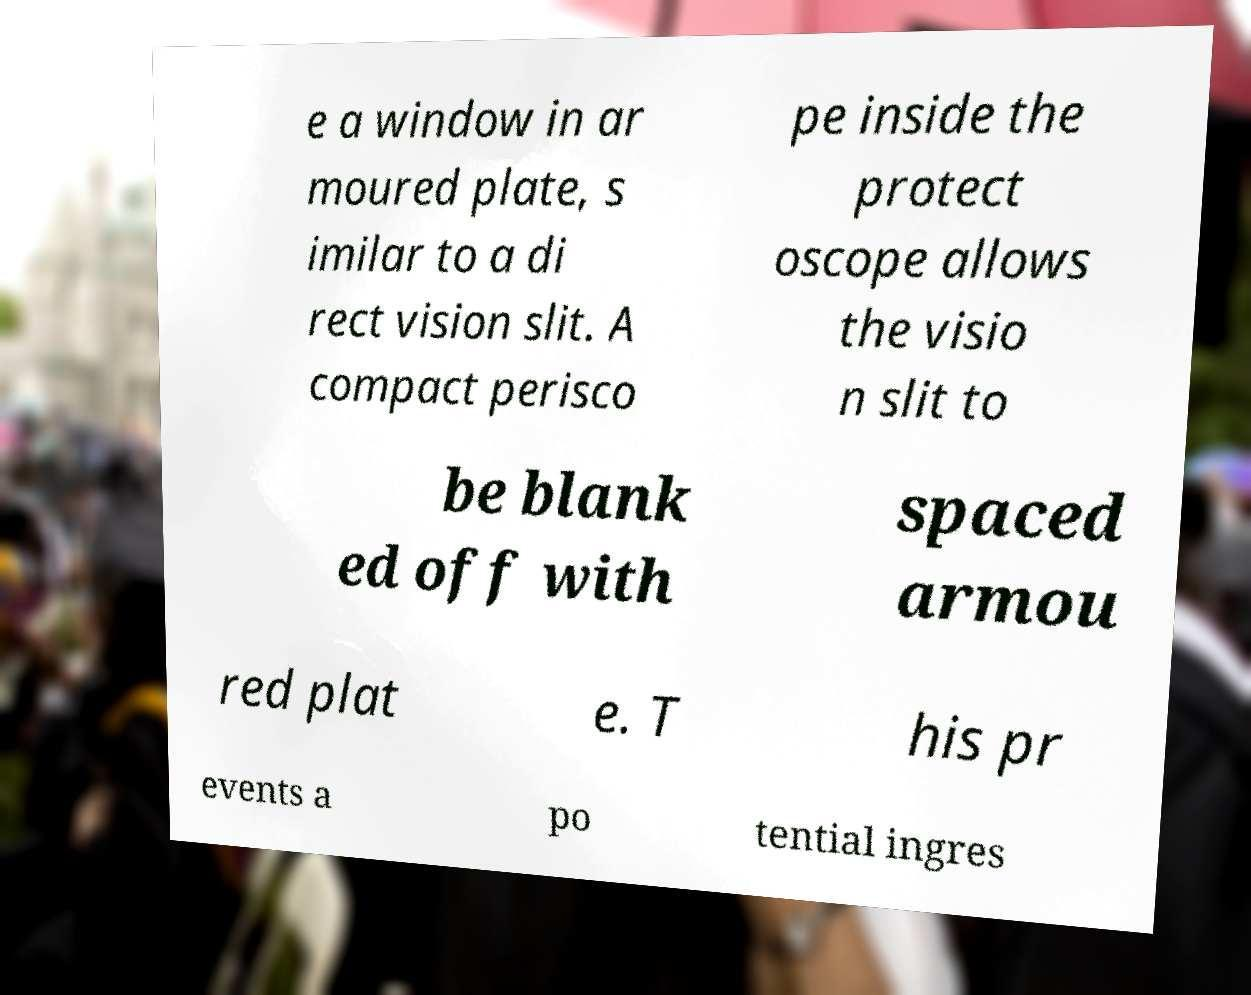Could you extract and type out the text from this image? e a window in ar moured plate, s imilar to a di rect vision slit. A compact perisco pe inside the protect oscope allows the visio n slit to be blank ed off with spaced armou red plat e. T his pr events a po tential ingres 